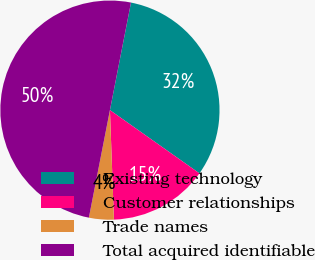Convert chart to OTSL. <chart><loc_0><loc_0><loc_500><loc_500><pie_chart><fcel>Existing technology<fcel>Customer relationships<fcel>Trade names<fcel>Total acquired identifiable<nl><fcel>31.71%<fcel>14.63%<fcel>3.66%<fcel>50.0%<nl></chart> 